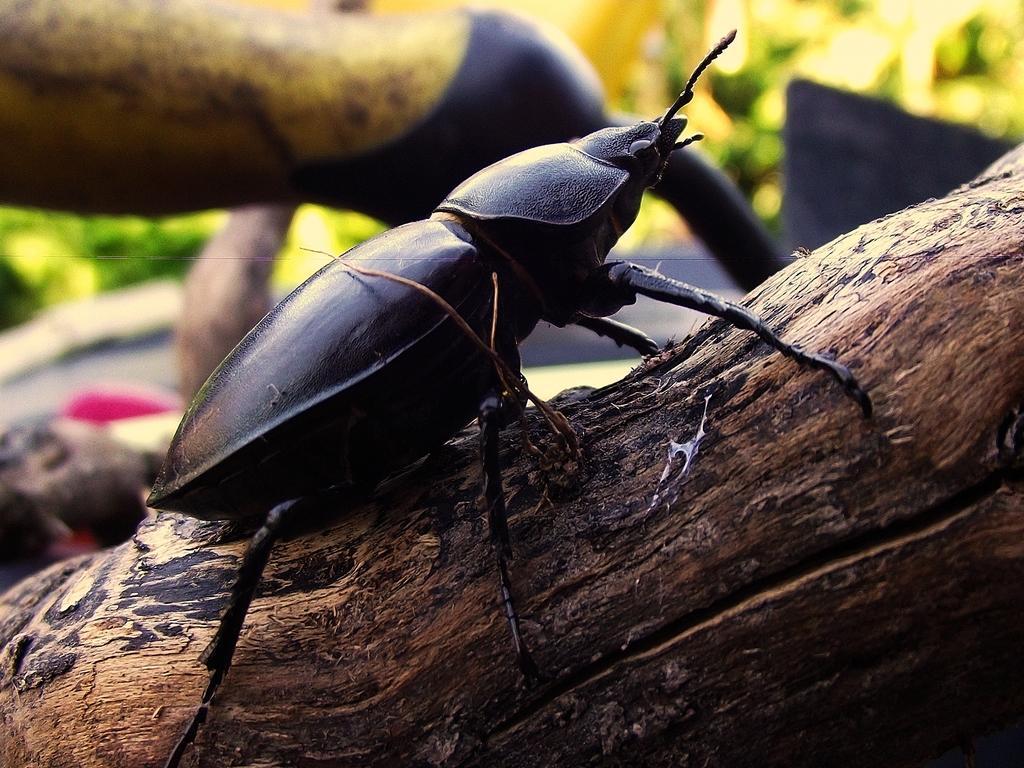Describe this image in one or two sentences. In the picture we can see a tree log on it, we can see an insect which is black in color with legs, and antenna and behind it we can see some plants which are not clearly visible. 